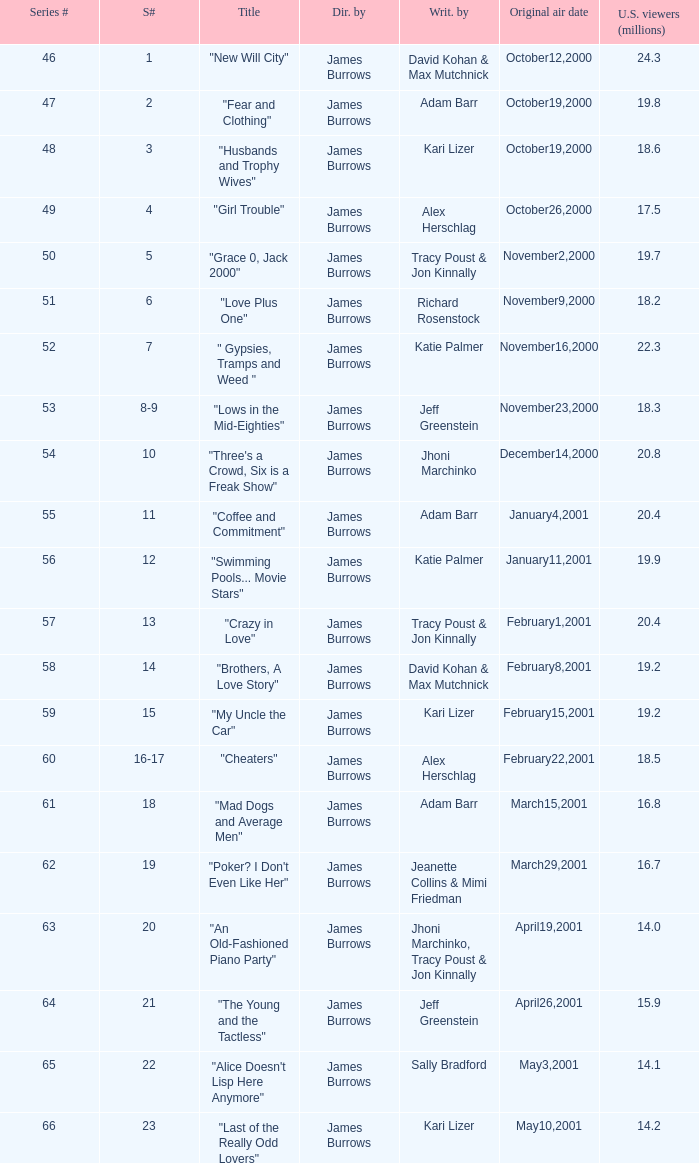Who wrote episode 23 in the season? Kari Lizer. Would you be able to parse every entry in this table? {'header': ['Series #', 'S#', 'Title', 'Dir. by', 'Writ. by', 'Original air date', 'U.S. viewers (millions)'], 'rows': [['46', '1', '"New Will City"', 'James Burrows', 'David Kohan & Max Mutchnick', 'October12,2000', '24.3'], ['47', '2', '"Fear and Clothing"', 'James Burrows', 'Adam Barr', 'October19,2000', '19.8'], ['48', '3', '"Husbands and Trophy Wives"', 'James Burrows', 'Kari Lizer', 'October19,2000', '18.6'], ['49', '4', '"Girl Trouble"', 'James Burrows', 'Alex Herschlag', 'October26,2000', '17.5'], ['50', '5', '"Grace 0, Jack 2000"', 'James Burrows', 'Tracy Poust & Jon Kinnally', 'November2,2000', '19.7'], ['51', '6', '"Love Plus One"', 'James Burrows', 'Richard Rosenstock', 'November9,2000', '18.2'], ['52', '7', '" Gypsies, Tramps and Weed "', 'James Burrows', 'Katie Palmer', 'November16,2000', '22.3'], ['53', '8-9', '"Lows in the Mid-Eighties"', 'James Burrows', 'Jeff Greenstein', 'November23,2000', '18.3'], ['54', '10', '"Three\'s a Crowd, Six is a Freak Show"', 'James Burrows', 'Jhoni Marchinko', 'December14,2000', '20.8'], ['55', '11', '"Coffee and Commitment"', 'James Burrows', 'Adam Barr', 'January4,2001', '20.4'], ['56', '12', '"Swimming Pools... Movie Stars"', 'James Burrows', 'Katie Palmer', 'January11,2001', '19.9'], ['57', '13', '"Crazy in Love"', 'James Burrows', 'Tracy Poust & Jon Kinnally', 'February1,2001', '20.4'], ['58', '14', '"Brothers, A Love Story"', 'James Burrows', 'David Kohan & Max Mutchnick', 'February8,2001', '19.2'], ['59', '15', '"My Uncle the Car"', 'James Burrows', 'Kari Lizer', 'February15,2001', '19.2'], ['60', '16-17', '"Cheaters"', 'James Burrows', 'Alex Herschlag', 'February22,2001', '18.5'], ['61', '18', '"Mad Dogs and Average Men"', 'James Burrows', 'Adam Barr', 'March15,2001', '16.8'], ['62', '19', '"Poker? I Don\'t Even Like Her"', 'James Burrows', 'Jeanette Collins & Mimi Friedman', 'March29,2001', '16.7'], ['63', '20', '"An Old-Fashioned Piano Party"', 'James Burrows', 'Jhoni Marchinko, Tracy Poust & Jon Kinnally', 'April19,2001', '14.0'], ['64', '21', '"The Young and the Tactless"', 'James Burrows', 'Jeff Greenstein', 'April26,2001', '15.9'], ['65', '22', '"Alice Doesn\'t Lisp Here Anymore"', 'James Burrows', 'Sally Bradford', 'May3,2001', '14.1'], ['66', '23', '"Last of the Really Odd Lovers"', 'James Burrows', 'Kari Lizer', 'May10,2001', '14.2']]} 